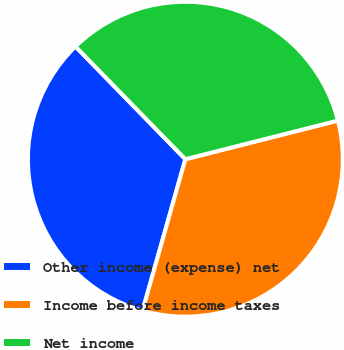<chart> <loc_0><loc_0><loc_500><loc_500><pie_chart><fcel>Other income (expense) net<fcel>Income before income taxes<fcel>Net income<nl><fcel>33.32%<fcel>33.33%<fcel>33.35%<nl></chart> 